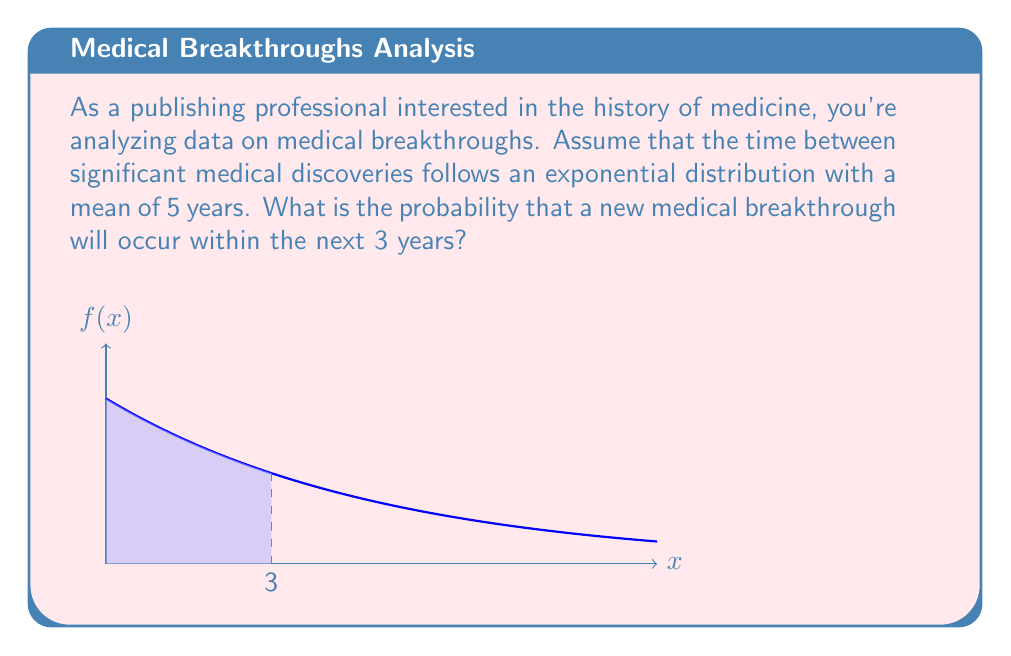Can you answer this question? Let's approach this step-by-step:

1) The exponential distribution is given by the probability density function:

   $$f(x) = \lambda e^{-\lambda x}$$

   where $\lambda$ is the rate parameter.

2) We're given that the mean is 5 years. For an exponential distribution, the mean is equal to $\frac{1}{\lambda}$. So:

   $$5 = \frac{1}{\lambda}$$
   $$\lambda = \frac{1}{5} = 0.2$$

3) The probability of an event occurring within time $t$ is given by the cumulative distribution function:

   $$P(X \leq t) = 1 - e^{-\lambda t}$$

4) We want to find the probability of a breakthrough within 3 years, so we substitute $t = 3$ and $\lambda = 0.2$:

   $$P(X \leq 3) = 1 - e^{-0.2 \cdot 3}$$

5) Let's calculate:

   $$P(X \leq 3) = 1 - e^{-0.6}$$
   $$= 1 - 0.5488$$
   $$= 0.4512$$

6) Therefore, the probability is approximately 0.4512 or 45.12%.
Answer: $0.4512$ or $45.12\%$ 